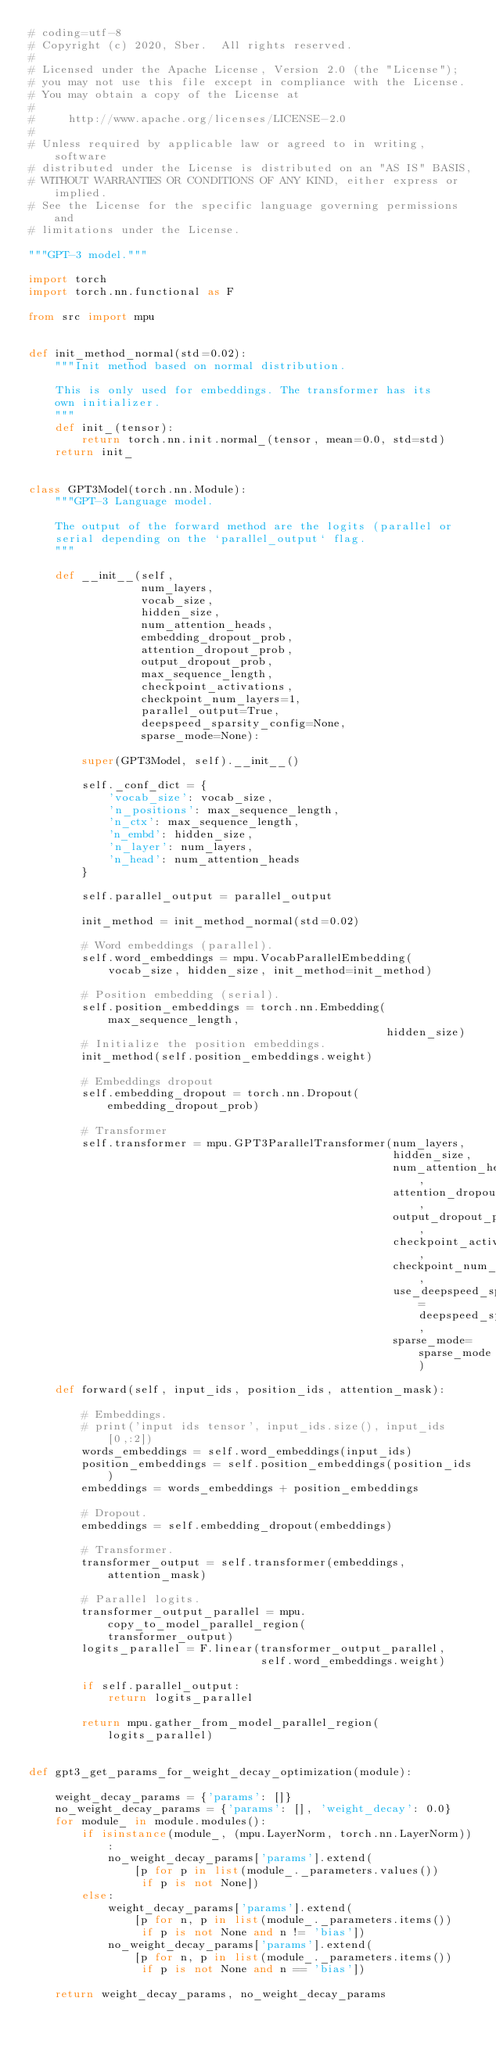<code> <loc_0><loc_0><loc_500><loc_500><_Python_># coding=utf-8
# Copyright (c) 2020, Sber.  All rights reserved.
#
# Licensed under the Apache License, Version 2.0 (the "License");
# you may not use this file except in compliance with the License.
# You may obtain a copy of the License at
#
#     http://www.apache.org/licenses/LICENSE-2.0
#
# Unless required by applicable law or agreed to in writing, software
# distributed under the License is distributed on an "AS IS" BASIS,
# WITHOUT WARRANTIES OR CONDITIONS OF ANY KIND, either express or implied.
# See the License for the specific language governing permissions and
# limitations under the License.

"""GPT-3 model."""

import torch
import torch.nn.functional as F

from src import mpu


def init_method_normal(std=0.02):
    """Init method based on normal distribution.

    This is only used for embeddings. The transformer has its
    own initializer.
    """
    def init_(tensor):
        return torch.nn.init.normal_(tensor, mean=0.0, std=std)
    return init_


class GPT3Model(torch.nn.Module):
    """GPT-3 Language model.

    The output of the forward method are the logits (parallel or
    serial depending on the `parallel_output` flag.
    """

    def __init__(self,
                 num_layers,
                 vocab_size,
                 hidden_size,
                 num_attention_heads,
                 embedding_dropout_prob,
                 attention_dropout_prob,
                 output_dropout_prob,
                 max_sequence_length,
                 checkpoint_activations,
                 checkpoint_num_layers=1,
                 parallel_output=True,
                 deepspeed_sparsity_config=None,
                 sparse_mode=None):

        super(GPT3Model, self).__init__()

        self._conf_dict = {
            'vocab_size': vocab_size,
            'n_positions': max_sequence_length,
            'n_ctx': max_sequence_length,
            'n_embd': hidden_size,
            'n_layer': num_layers,
            'n_head': num_attention_heads
        }

        self.parallel_output = parallel_output

        init_method = init_method_normal(std=0.02)

        # Word embeddings (parallel).
        self.word_embeddings = mpu.VocabParallelEmbedding(
            vocab_size, hidden_size, init_method=init_method)

        # Position embedding (serial).
        self.position_embeddings = torch.nn.Embedding(max_sequence_length,
                                                      hidden_size)
        # Initialize the position embeddings.
        init_method(self.position_embeddings.weight)

        # Embeddings dropout
        self.embedding_dropout = torch.nn.Dropout(embedding_dropout_prob)

        # Transformer
        self.transformer = mpu.GPT3ParallelTransformer(num_layers,
                                                       hidden_size,
                                                       num_attention_heads,
                                                       attention_dropout_prob,
                                                       output_dropout_prob,
                                                       checkpoint_activations,
                                                       checkpoint_num_layers,
                                                       use_deepspeed_sparse=deepspeed_sparsity_config,
                                                       sparse_mode=sparse_mode)

    def forward(self, input_ids, position_ids, attention_mask):

        # Embeddings.
        # print('input ids tensor', input_ids.size(), input_ids[0,:2])
        words_embeddings = self.word_embeddings(input_ids)
        position_embeddings = self.position_embeddings(position_ids)
        embeddings = words_embeddings + position_embeddings

        # Dropout.
        embeddings = self.embedding_dropout(embeddings)

        # Transformer.
        transformer_output = self.transformer(embeddings, attention_mask)

        # Parallel logits.
        transformer_output_parallel = mpu.copy_to_model_parallel_region(
            transformer_output)
        logits_parallel = F.linear(transformer_output_parallel,
                                   self.word_embeddings.weight)

        if self.parallel_output:
            return logits_parallel

        return mpu.gather_from_model_parallel_region(logits_parallel)


def gpt3_get_params_for_weight_decay_optimization(module):

    weight_decay_params = {'params': []}
    no_weight_decay_params = {'params': [], 'weight_decay': 0.0}
    for module_ in module.modules():
        if isinstance(module_, (mpu.LayerNorm, torch.nn.LayerNorm)):
            no_weight_decay_params['params'].extend(
                [p for p in list(module_._parameters.values())
                 if p is not None])
        else:
            weight_decay_params['params'].extend(
                [p for n, p in list(module_._parameters.items())
                 if p is not None and n != 'bias'])
            no_weight_decay_params['params'].extend(
                [p for n, p in list(module_._parameters.items())
                 if p is not None and n == 'bias'])

    return weight_decay_params, no_weight_decay_params
</code> 